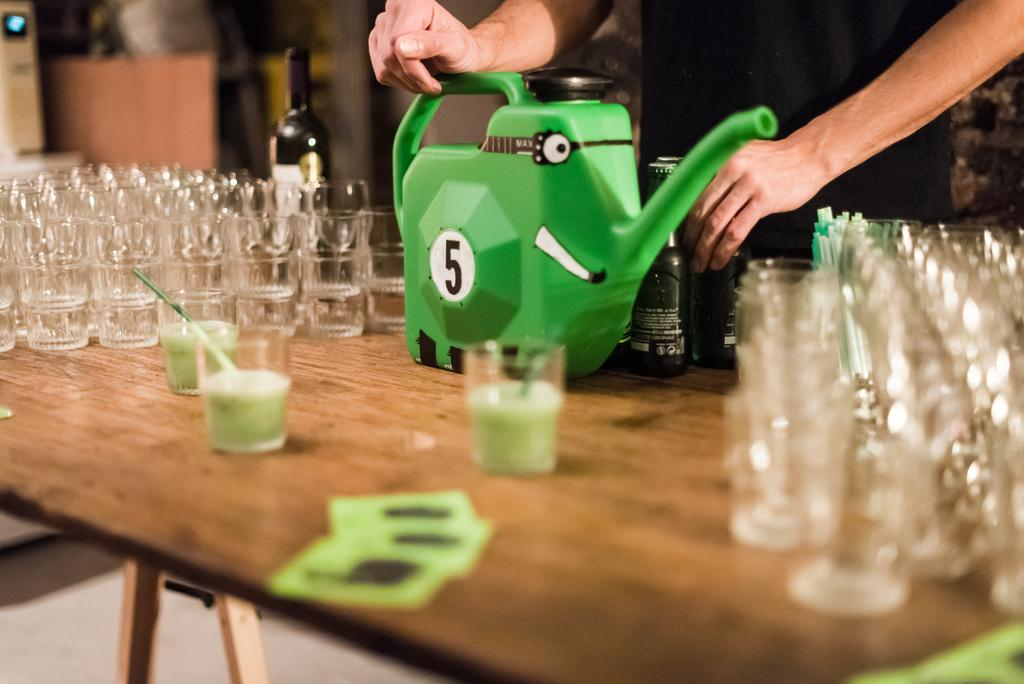What type of objects are made of glass in the image? There are glass objects in the image. What is used for drinking in the image? There is a straw in the image, which is typically used for drinking. What is the person in the image holding? The person in the image is holding a cane. How many bottles are on the table in the image? There are two bottles on a table in the image. Can you describe the person in the background of the image? There is a person standing in the background of the image. What type of animal can be seen at the zoo in the image? There is no zoo or animal present in the image. How many eyes does the person in the image have? The number of eyes cannot be determined from the image, as it only shows a person standing in the background. 